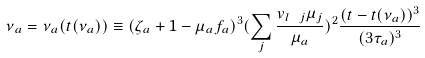<formula> <loc_0><loc_0><loc_500><loc_500>\nu _ { a } = \nu _ { a } ( t ( \nu _ { a } ) ) \equiv ( \zeta _ { a } + 1 - \mu _ { a } f _ { a } ) ^ { 3 } ( \sum _ { j } \frac { v _ { l \ j } \mu _ { j } } { \mu _ { a } } ) ^ { 2 } \frac { ( t - t ( \nu _ { a } ) ) ^ { 3 } } { ( 3 \tau _ { a } ) ^ { 3 } }</formula> 